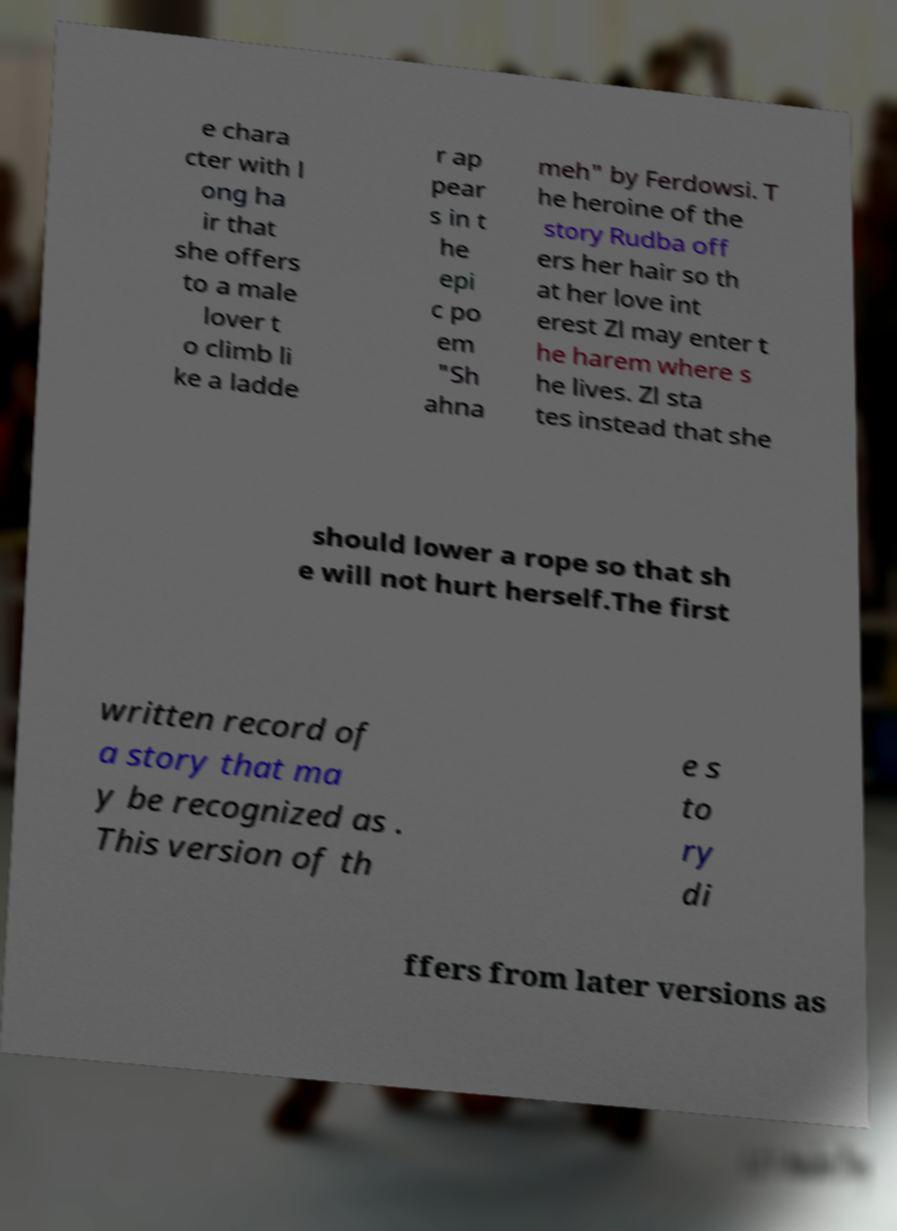Can you read and provide the text displayed in the image?This photo seems to have some interesting text. Can you extract and type it out for me? e chara cter with l ong ha ir that she offers to a male lover t o climb li ke a ladde r ap pear s in t he epi c po em "Sh ahna meh" by Ferdowsi. T he heroine of the story Rudba off ers her hair so th at her love int erest Zl may enter t he harem where s he lives. Zl sta tes instead that she should lower a rope so that sh e will not hurt herself.The first written record of a story that ma y be recognized as . This version of th e s to ry di ffers from later versions as 